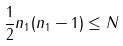Convert formula to latex. <formula><loc_0><loc_0><loc_500><loc_500>\frac { 1 } { 2 } n _ { 1 } ( n _ { 1 } - 1 ) \leq N</formula> 